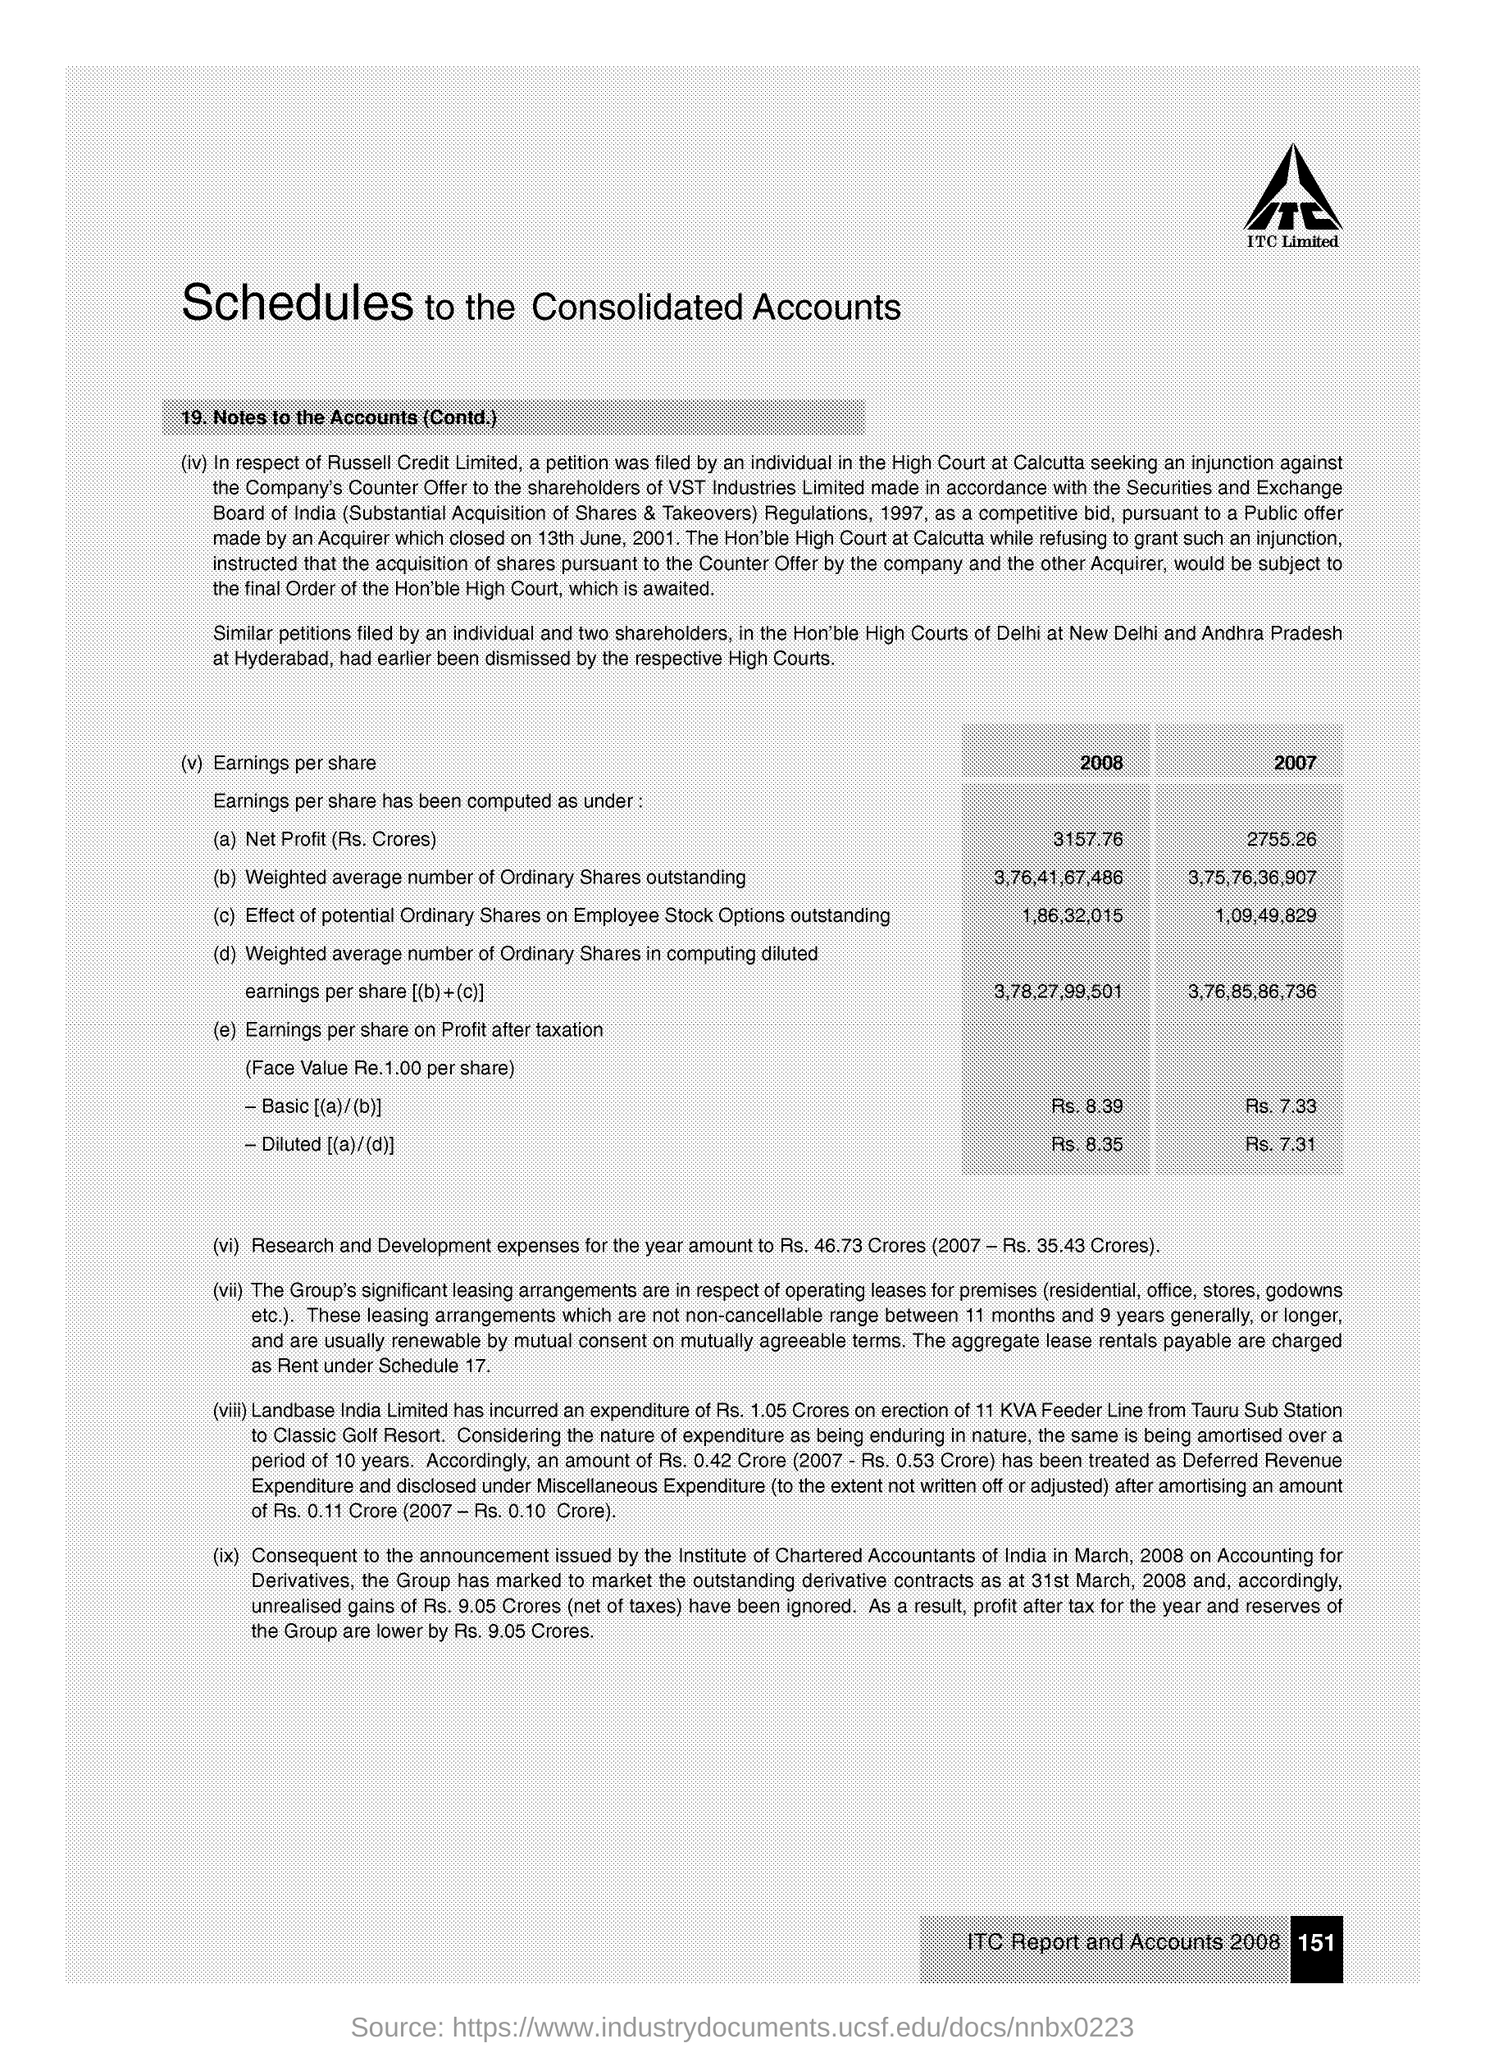What is the Net Profit (Rs. Crores) in the year 2008?
Make the answer very short. 3157.76. How much are the Research and Development expenses for the year?
Your response must be concise. Rs. 46.73 Crores (2007 - Rs. 35.43 Crores). 